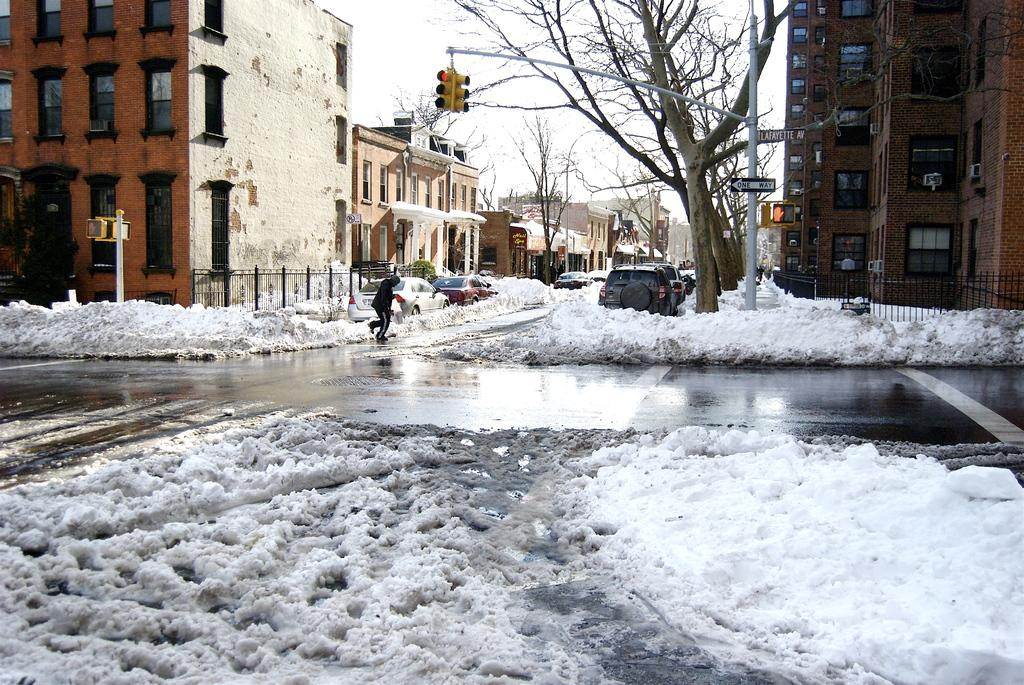What is the condition of the road in the image? The road is covered with snow in the image. What can be seen on the road? There are cars on the road in the image. What is the man in the image doing? The man is walking in the image. What can be seen in the background of the image? There are buildings, trees, signal poles, and the sky visible in the background of the image. What type of note is the man holding while walking in the image? There is no note present in the image; the man is simply walking. Can you tell me how many glasses of eggnog are visible in the image? There is no eggnog present in the image. 